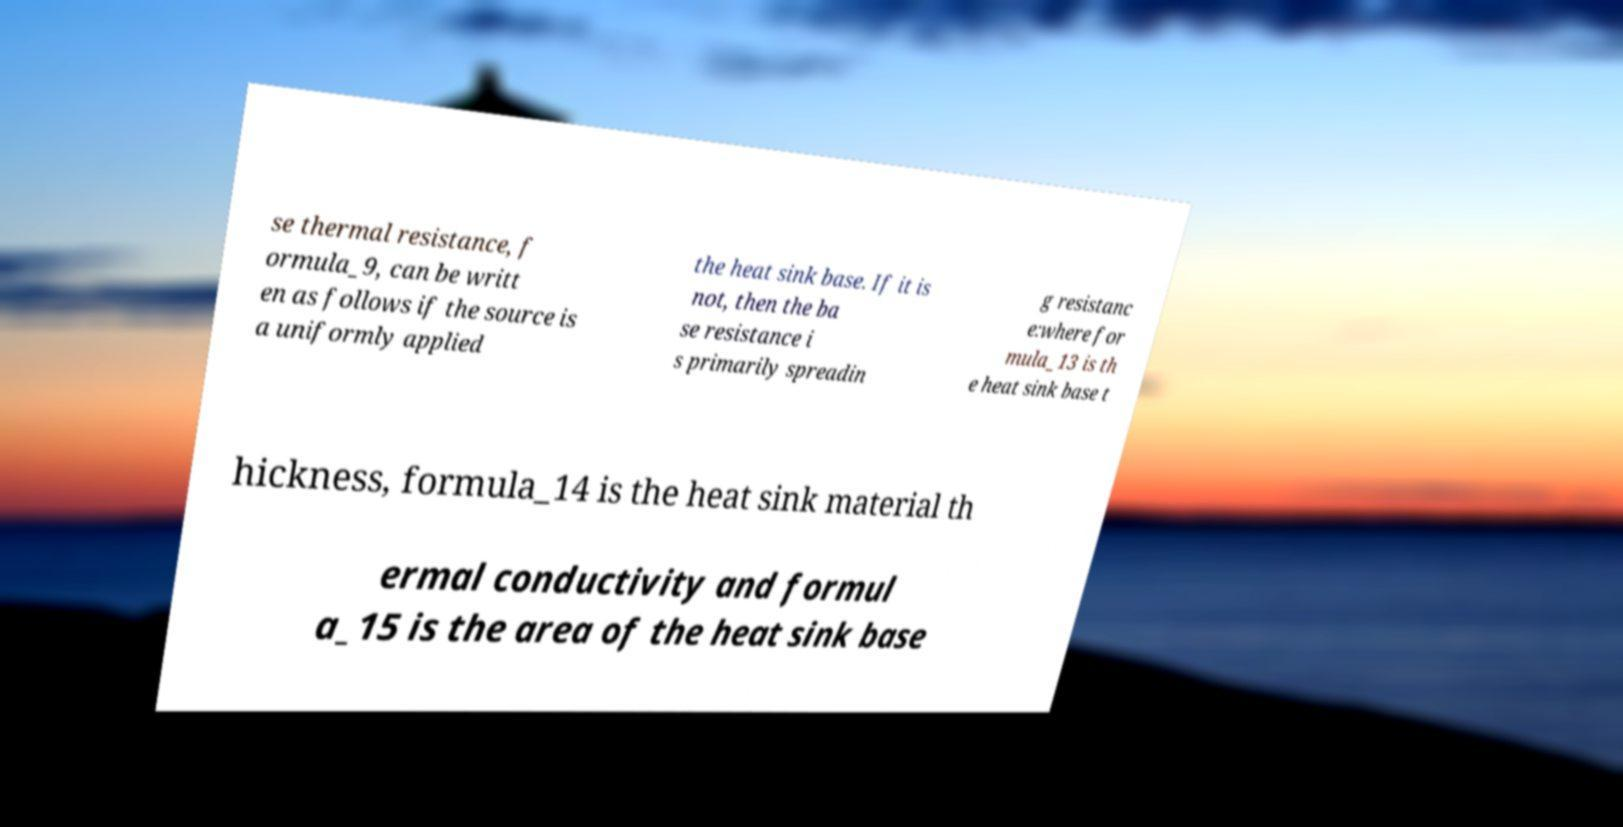Could you extract and type out the text from this image? se thermal resistance, f ormula_9, can be writt en as follows if the source is a uniformly applied the heat sink base. If it is not, then the ba se resistance i s primarily spreadin g resistanc e:where for mula_13 is th e heat sink base t hickness, formula_14 is the heat sink material th ermal conductivity and formul a_15 is the area of the heat sink base 